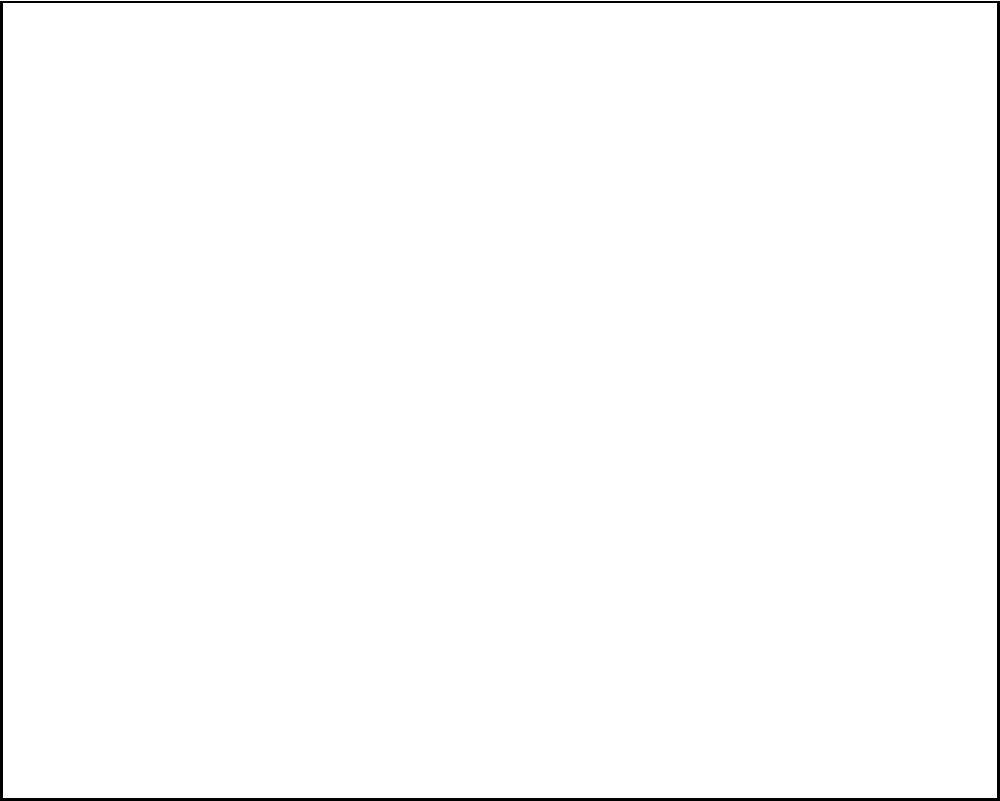In a quaint cinema that exclusively shows B-movies and cult classics, the theater layout is represented above. Each dot represents a seat, and the red dots indicate the optimal viewing positions. If you were to choose the best seat for enjoying the delightful cheesiness of "Plan 9 from Outer Space," which row and seat would you select? (Use the letter for the column and the number for the row, counting from the bottom.) To determine the best seat for enjoying a cheesy B-movie, we need to consider the following steps:

1. Observe the theater layout: The cinema has 5 columns (A-E) and 4 rows.

2. Identify the optimal viewing positions: The red dots indicate these positions, which are in the 3rd row from the bottom.

3. Analyze the red dot positions: There are two red dots, symmetrically placed in columns B and D.

4. Consider the viewing experience: For a B-movie enthusiast who appreciates the cheesiness, a slightly off-center view might enhance the experience by highlighting the film's imperfections.

5. Choose the best seat: Between the two optimal positions, the seat in column B (closer to the left) would be preferable. This is because:
   a) It's slightly off-center, providing a unique perspective on the film's quirks.
   b) In Western cinema, action typically moves from left to right, so this position might offer a slight advantage in following the (likely convoluted) plot.

6. Determine the seat coordinates: The chosen seat is in column B, 3rd row from the bottom.

Therefore, the best seat for enjoying "Plan 9 from Outer Space" would be B3.
Answer: B3 